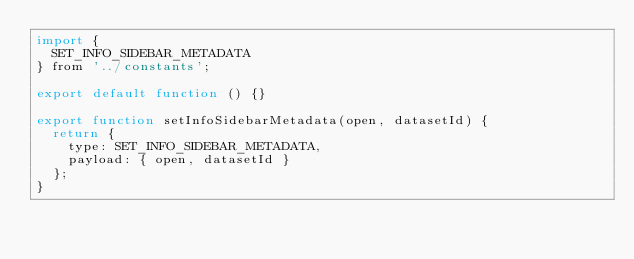Convert code to text. <code><loc_0><loc_0><loc_500><loc_500><_JavaScript_>import {
  SET_INFO_SIDEBAR_METADATA
} from '../constants';

export default function () {}

export function setInfoSidebarMetadata(open, datasetId) {
  return {
    type: SET_INFO_SIDEBAR_METADATA,
    payload: { open, datasetId }
  };
}
</code> 